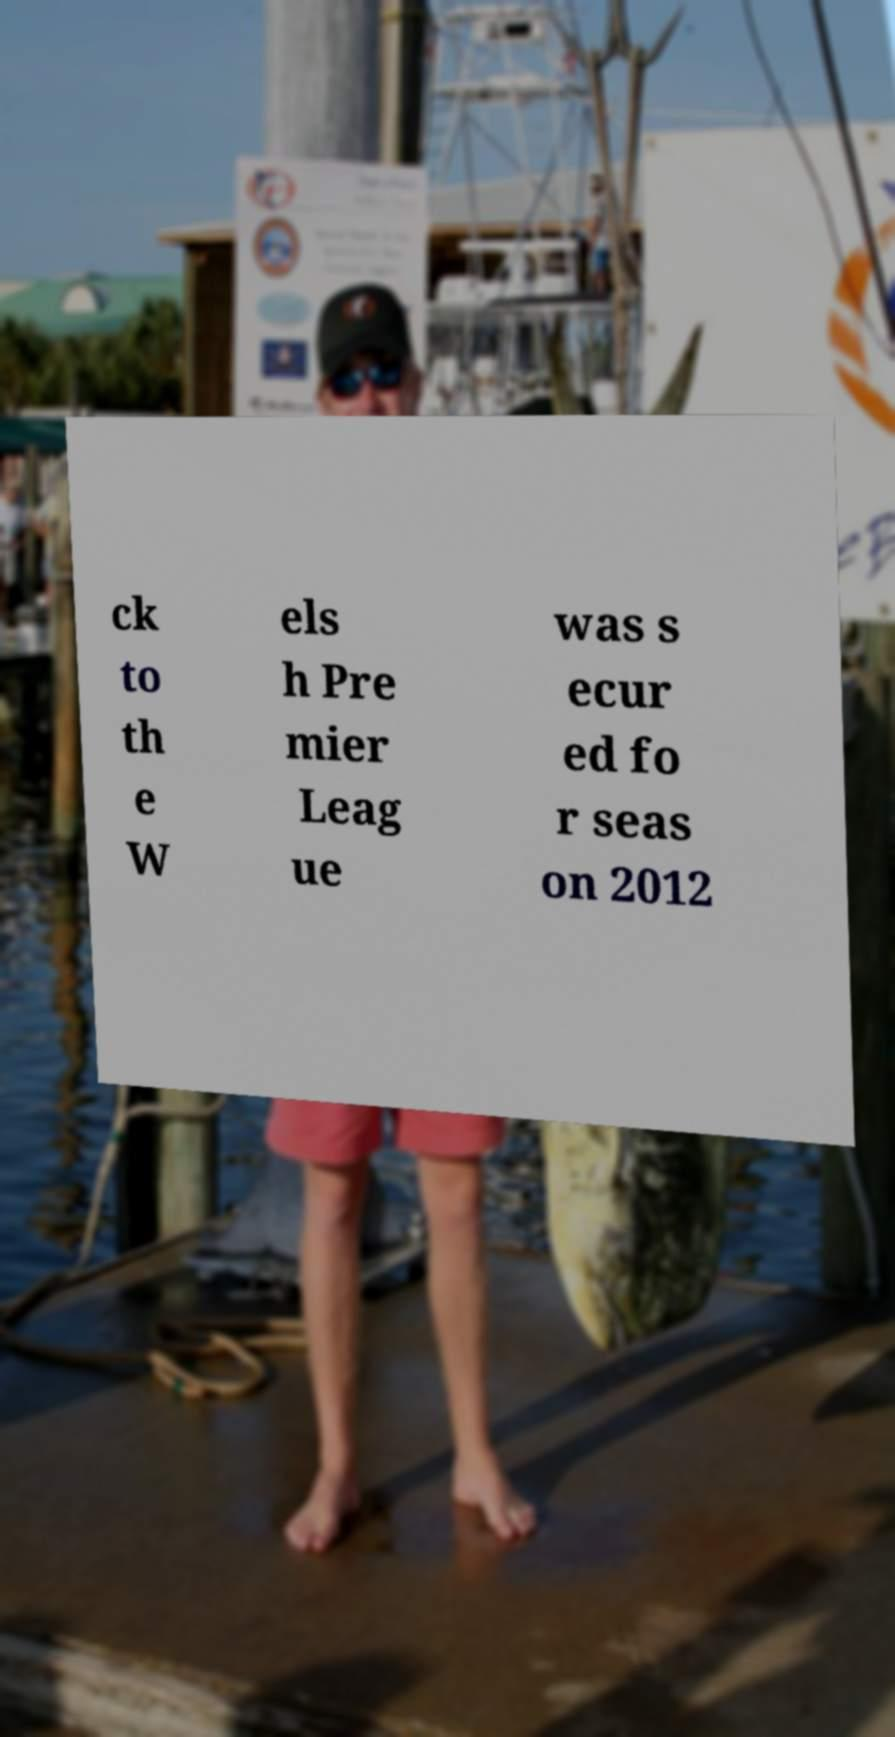Can you read and provide the text displayed in the image?This photo seems to have some interesting text. Can you extract and type it out for me? ck to th e W els h Pre mier Leag ue was s ecur ed fo r seas on 2012 